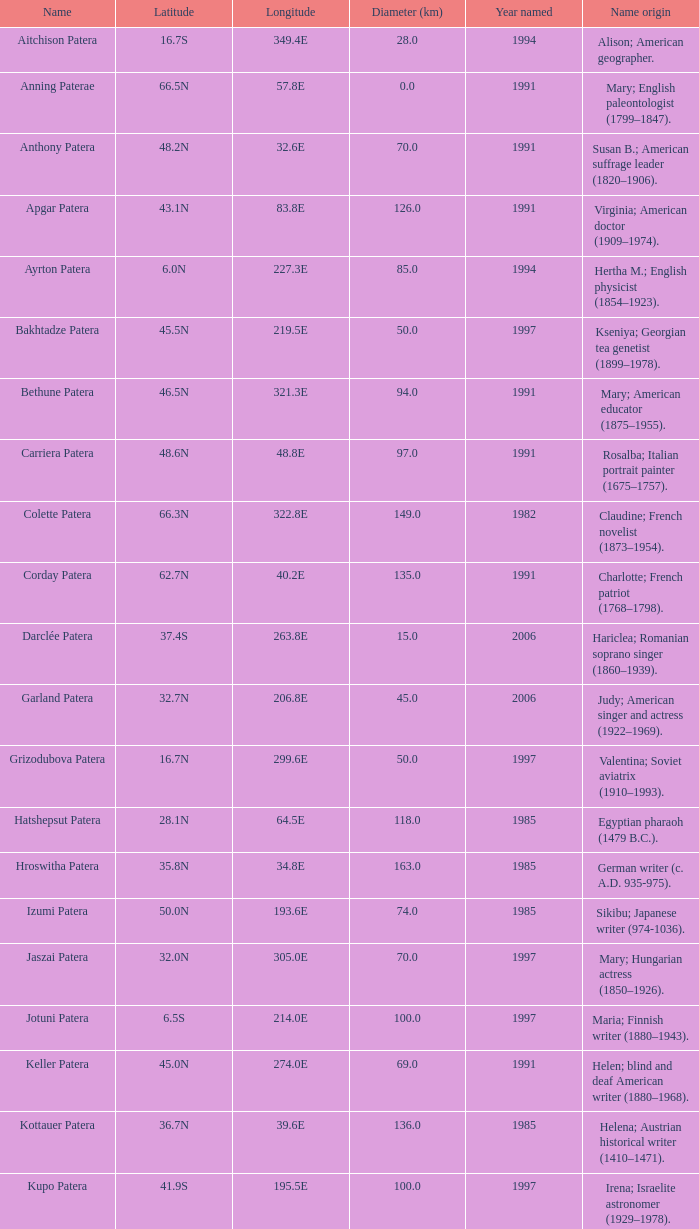What is  the diameter in km of the feature with a longitude of 40.2E?  135.0. 